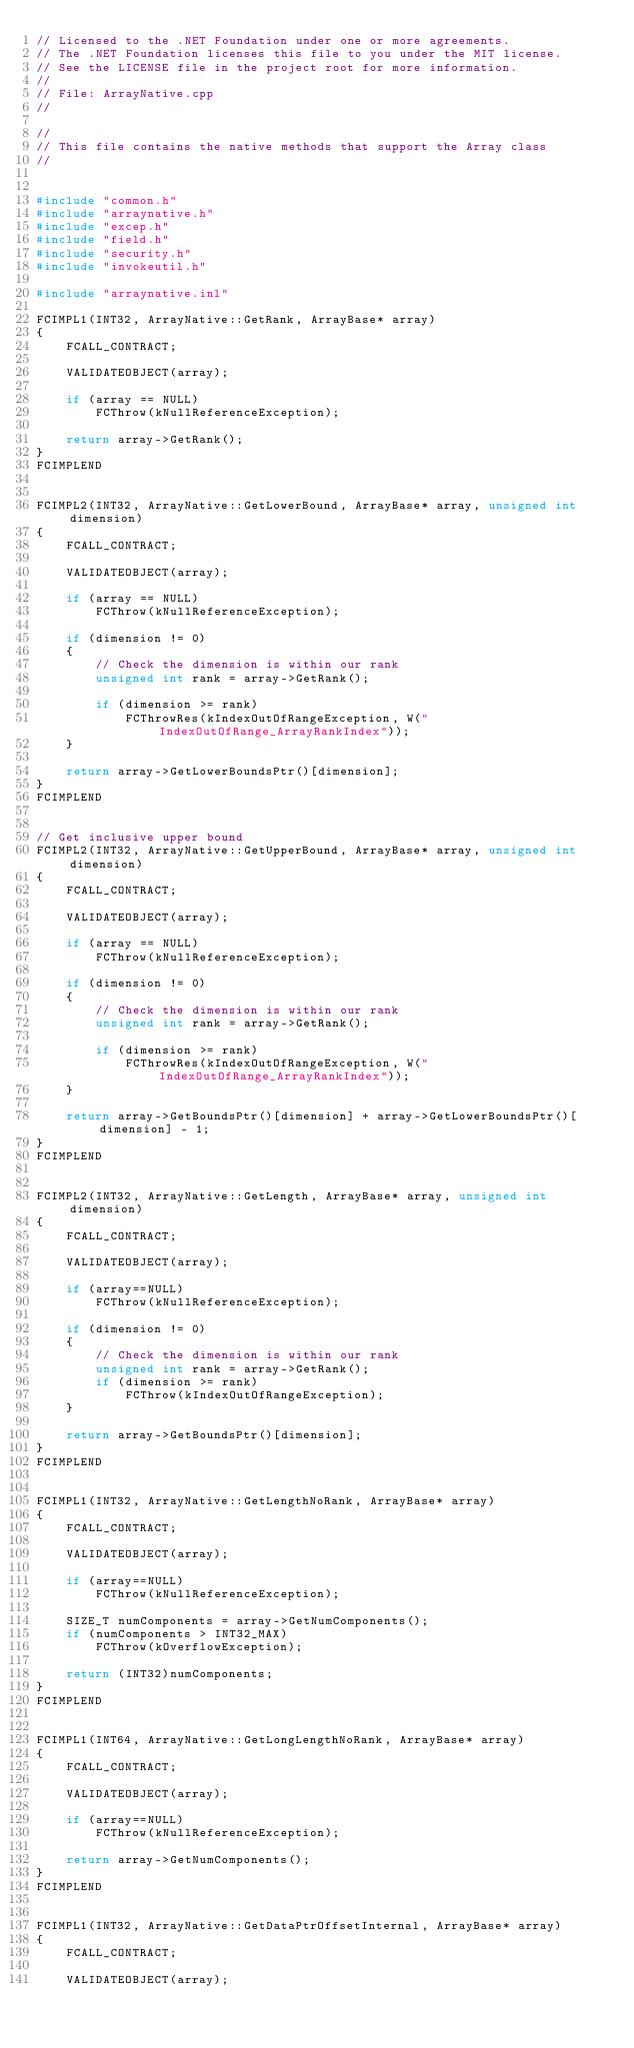Convert code to text. <code><loc_0><loc_0><loc_500><loc_500><_C++_>// Licensed to the .NET Foundation under one or more agreements.
// The .NET Foundation licenses this file to you under the MIT license.
// See the LICENSE file in the project root for more information.
//
// File: ArrayNative.cpp
//

//
// This file contains the native methods that support the Array class
//


#include "common.h"
#include "arraynative.h"
#include "excep.h"
#include "field.h"
#include "security.h"
#include "invokeutil.h"

#include "arraynative.inl"

FCIMPL1(INT32, ArrayNative::GetRank, ArrayBase* array)
{
    FCALL_CONTRACT;

    VALIDATEOBJECT(array);

    if (array == NULL)
        FCThrow(kNullReferenceException);

    return array->GetRank();
}
FCIMPLEND


FCIMPL2(INT32, ArrayNative::GetLowerBound, ArrayBase* array, unsigned int dimension)
{
    FCALL_CONTRACT;

    VALIDATEOBJECT(array);

    if (array == NULL)
        FCThrow(kNullReferenceException);
    
    if (dimension != 0)
    {
        // Check the dimension is within our rank
        unsigned int rank = array->GetRank();
    
        if (dimension >= rank)
            FCThrowRes(kIndexOutOfRangeException, W("IndexOutOfRange_ArrayRankIndex"));
    }

    return array->GetLowerBoundsPtr()[dimension];
}
FCIMPLEND


// Get inclusive upper bound
FCIMPL2(INT32, ArrayNative::GetUpperBound, ArrayBase* array, unsigned int dimension)
{
    FCALL_CONTRACT;

    VALIDATEOBJECT(array);

    if (array == NULL)
        FCThrow(kNullReferenceException);
    
    if (dimension != 0)
    {
        // Check the dimension is within our rank
        unsigned int rank = array->GetRank();
    
        if (dimension >= rank)
            FCThrowRes(kIndexOutOfRangeException, W("IndexOutOfRange_ArrayRankIndex"));
    }

    return array->GetBoundsPtr()[dimension] + array->GetLowerBoundsPtr()[dimension] - 1;
}
FCIMPLEND


FCIMPL2(INT32, ArrayNative::GetLength, ArrayBase* array, unsigned int dimension)
{
    FCALL_CONTRACT;

    VALIDATEOBJECT(array);

    if (array==NULL)
        FCThrow(kNullReferenceException);
    
    if (dimension != 0)
    {
        // Check the dimension is within our rank
        unsigned int rank = array->GetRank();
        if (dimension >= rank)
            FCThrow(kIndexOutOfRangeException);
    }
    
    return array->GetBoundsPtr()[dimension];
}
FCIMPLEND


FCIMPL1(INT32, ArrayNative::GetLengthNoRank, ArrayBase* array)
{
    FCALL_CONTRACT;

    VALIDATEOBJECT(array);

    if (array==NULL)
        FCThrow(kNullReferenceException);

    SIZE_T numComponents = array->GetNumComponents();
    if (numComponents > INT32_MAX)
        FCThrow(kOverflowException);

    return (INT32)numComponents;
}
FCIMPLEND


FCIMPL1(INT64, ArrayNative::GetLongLengthNoRank, ArrayBase* array)
{
    FCALL_CONTRACT;

    VALIDATEOBJECT(array);

    if (array==NULL)
        FCThrow(kNullReferenceException);

    return array->GetNumComponents();
}
FCIMPLEND


FCIMPL1(INT32, ArrayNative::GetDataPtrOffsetInternal, ArrayBase* array)
{
    FCALL_CONTRACT;

    VALIDATEOBJECT(array);
</code> 